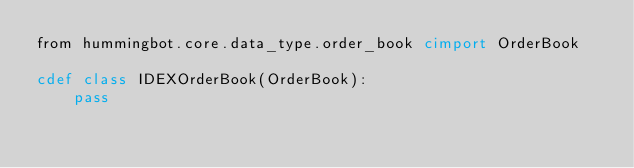<code> <loc_0><loc_0><loc_500><loc_500><_Cython_>from hummingbot.core.data_type.order_book cimport OrderBook

cdef class IDEXOrderBook(OrderBook):
    pass
</code> 